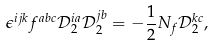<formula> <loc_0><loc_0><loc_500><loc_500>\epsilon ^ { i j k } f ^ { a b c } \mathcal { D } _ { 2 } ^ { i a } \mathcal { D } _ { 2 } ^ { j b } = - \frac { 1 } { 2 } N _ { f } \mathcal { D } _ { 2 } ^ { k c } ,</formula> 